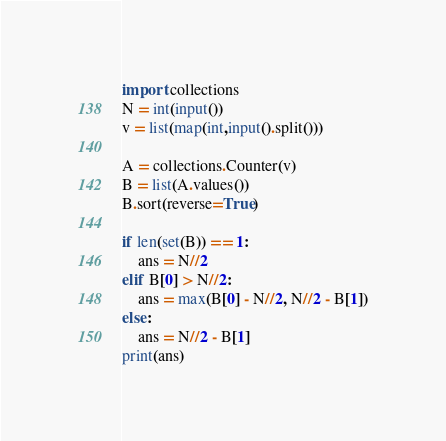Convert code to text. <code><loc_0><loc_0><loc_500><loc_500><_Python_>import collections
N = int(input())
v = list(map(int,input().split()))

A = collections.Counter(v)
B = list(A.values())
B.sort(reverse=True)

if len(set(B)) == 1:
    ans = N//2
elif B[0] > N//2:
    ans = max(B[0] - N//2, N//2 - B[1])
else:
    ans = N//2 - B[1]
print(ans)</code> 